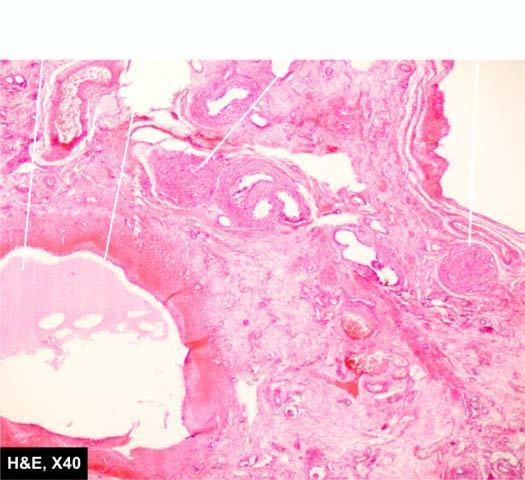what consists of primitive connective tissue and cartilage?
Answer the question using a single word or phrase. Intervening parenchyma 